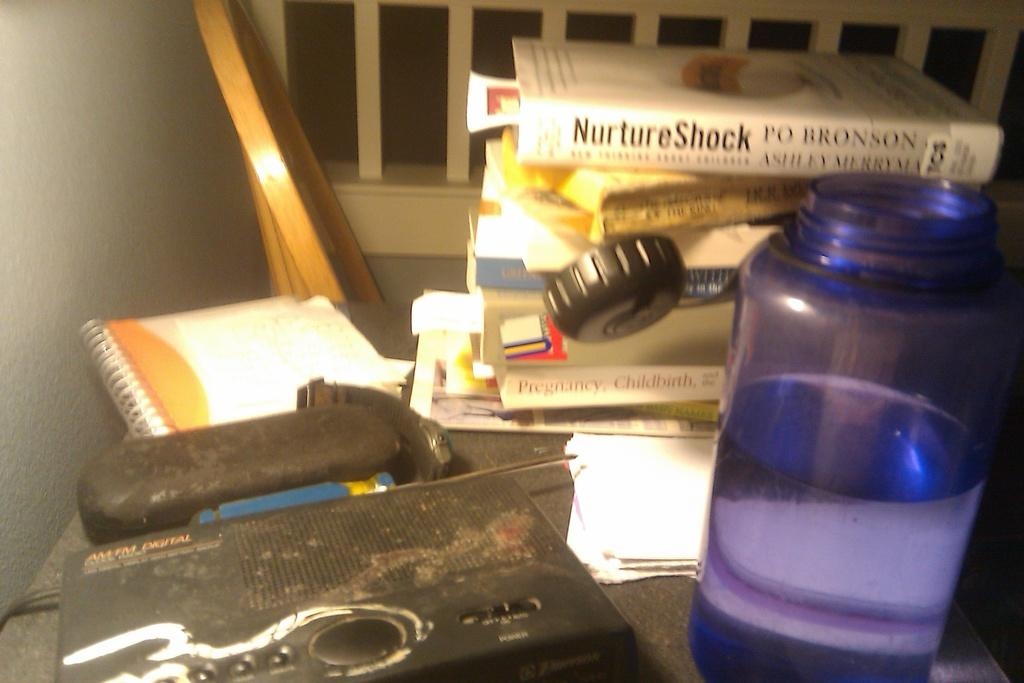<image>
Provide a brief description of the given image. A collection of books including NurtureShock by Po Bronson. 